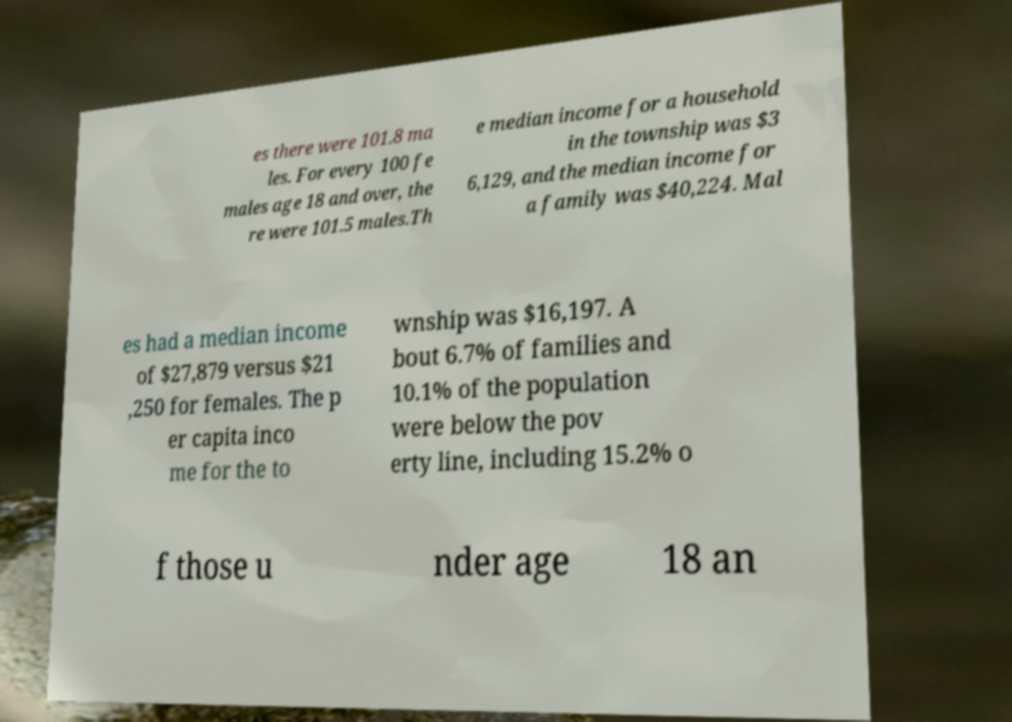Could you assist in decoding the text presented in this image and type it out clearly? es there were 101.8 ma les. For every 100 fe males age 18 and over, the re were 101.5 males.Th e median income for a household in the township was $3 6,129, and the median income for a family was $40,224. Mal es had a median income of $27,879 versus $21 ,250 for females. The p er capita inco me for the to wnship was $16,197. A bout 6.7% of families and 10.1% of the population were below the pov erty line, including 15.2% o f those u nder age 18 an 